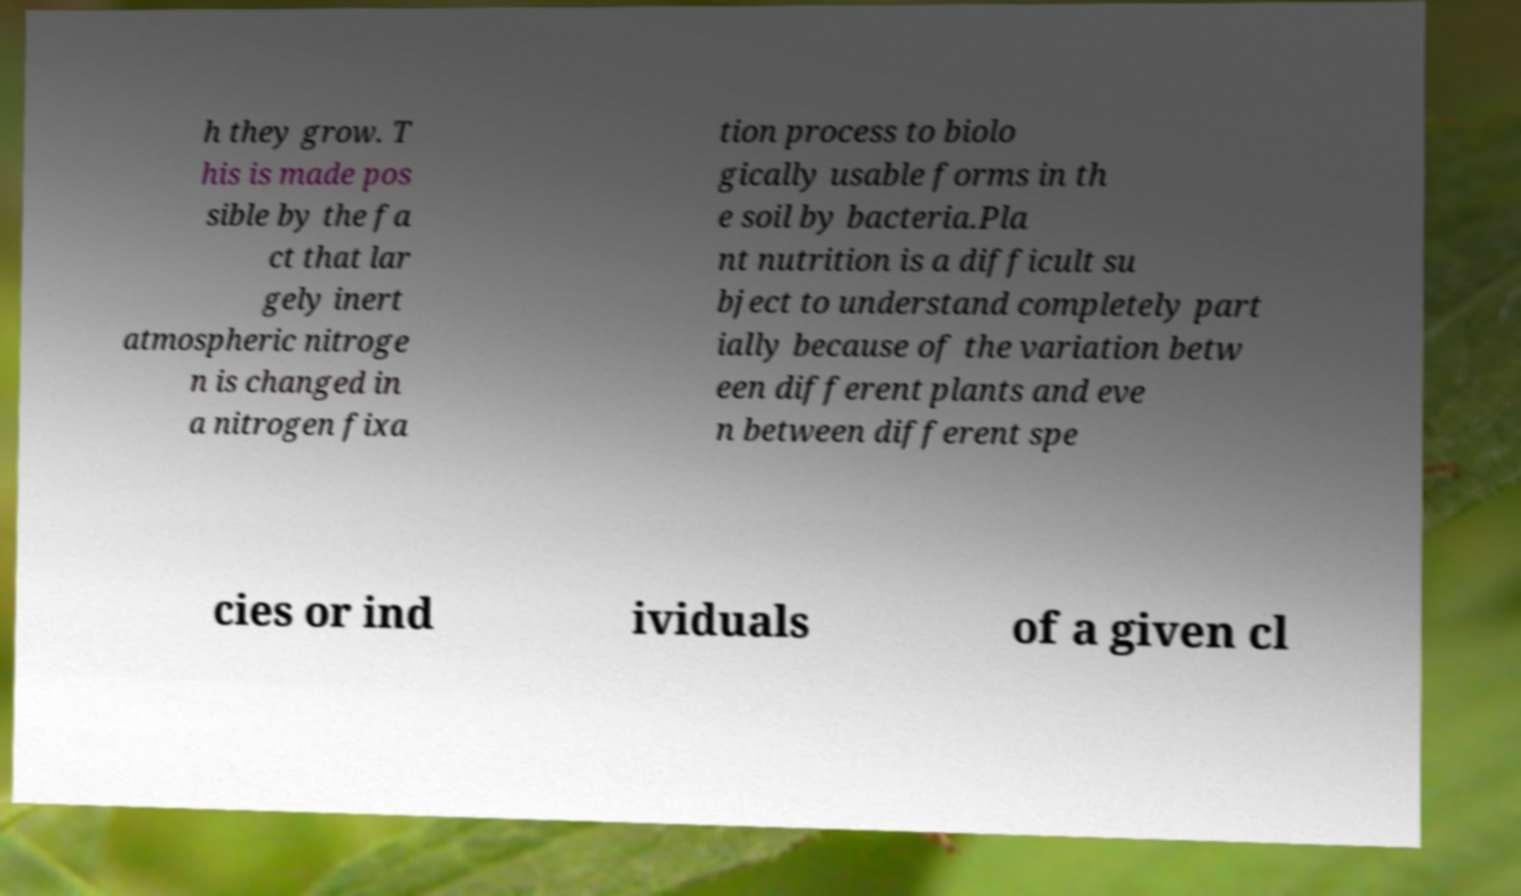Please read and relay the text visible in this image. What does it say? h they grow. T his is made pos sible by the fa ct that lar gely inert atmospheric nitroge n is changed in a nitrogen fixa tion process to biolo gically usable forms in th e soil by bacteria.Pla nt nutrition is a difficult su bject to understand completely part ially because of the variation betw een different plants and eve n between different spe cies or ind ividuals of a given cl 